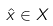<formula> <loc_0><loc_0><loc_500><loc_500>\hat { x } \in X</formula> 